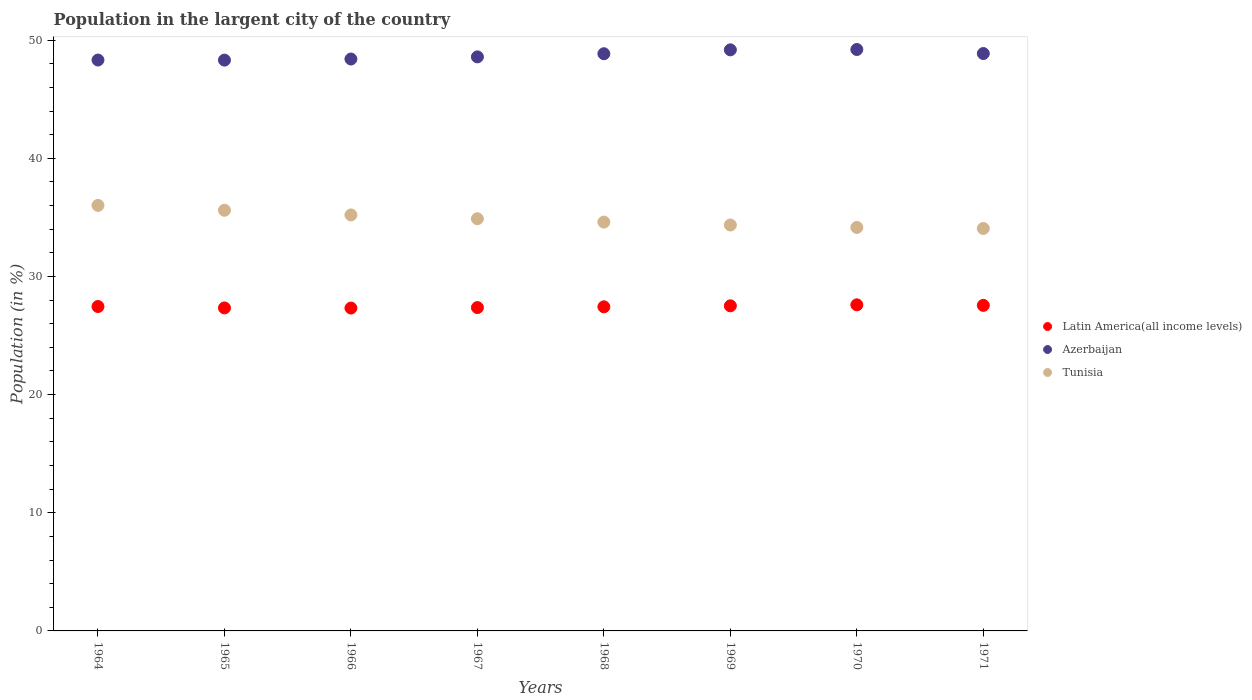What is the percentage of population in the largent city in Azerbaijan in 1965?
Ensure brevity in your answer.  48.31. Across all years, what is the maximum percentage of population in the largent city in Latin America(all income levels)?
Give a very brief answer. 27.6. Across all years, what is the minimum percentage of population in the largent city in Azerbaijan?
Give a very brief answer. 48.31. What is the total percentage of population in the largent city in Latin America(all income levels) in the graph?
Offer a very short reply. 219.59. What is the difference between the percentage of population in the largent city in Azerbaijan in 1964 and that in 1970?
Your response must be concise. -0.89. What is the difference between the percentage of population in the largent city in Tunisia in 1967 and the percentage of population in the largent city in Latin America(all income levels) in 1964?
Ensure brevity in your answer.  7.43. What is the average percentage of population in the largent city in Azerbaijan per year?
Give a very brief answer. 48.72. In the year 1967, what is the difference between the percentage of population in the largent city in Tunisia and percentage of population in the largent city in Azerbaijan?
Ensure brevity in your answer.  -13.7. What is the ratio of the percentage of population in the largent city in Tunisia in 1964 to that in 1965?
Keep it short and to the point. 1.01. Is the percentage of population in the largent city in Azerbaijan in 1968 less than that in 1970?
Your answer should be very brief. Yes. What is the difference between the highest and the second highest percentage of population in the largent city in Latin America(all income levels)?
Your answer should be compact. 0.05. What is the difference between the highest and the lowest percentage of population in the largent city in Latin America(all income levels)?
Make the answer very short. 0.27. How many dotlines are there?
Offer a terse response. 3. Are the values on the major ticks of Y-axis written in scientific E-notation?
Give a very brief answer. No. Does the graph contain any zero values?
Your response must be concise. No. Where does the legend appear in the graph?
Keep it short and to the point. Center right. How many legend labels are there?
Your answer should be compact. 3. What is the title of the graph?
Your answer should be compact. Population in the largent city of the country. What is the Population (in %) of Latin America(all income levels) in 1964?
Keep it short and to the point. 27.46. What is the Population (in %) in Azerbaijan in 1964?
Keep it short and to the point. 48.32. What is the Population (in %) in Tunisia in 1964?
Give a very brief answer. 36.02. What is the Population (in %) of Latin America(all income levels) in 1965?
Provide a short and direct response. 27.34. What is the Population (in %) in Azerbaijan in 1965?
Make the answer very short. 48.31. What is the Population (in %) of Tunisia in 1965?
Make the answer very short. 35.6. What is the Population (in %) of Latin America(all income levels) in 1966?
Make the answer very short. 27.33. What is the Population (in %) in Azerbaijan in 1966?
Your answer should be very brief. 48.4. What is the Population (in %) of Tunisia in 1966?
Give a very brief answer. 35.21. What is the Population (in %) of Latin America(all income levels) in 1967?
Give a very brief answer. 27.37. What is the Population (in %) of Azerbaijan in 1967?
Ensure brevity in your answer.  48.59. What is the Population (in %) in Tunisia in 1967?
Make the answer very short. 34.89. What is the Population (in %) in Latin America(all income levels) in 1968?
Offer a very short reply. 27.43. What is the Population (in %) in Azerbaijan in 1968?
Your response must be concise. 48.85. What is the Population (in %) of Tunisia in 1968?
Keep it short and to the point. 34.6. What is the Population (in %) of Latin America(all income levels) in 1969?
Make the answer very short. 27.52. What is the Population (in %) in Azerbaijan in 1969?
Offer a very short reply. 49.18. What is the Population (in %) of Tunisia in 1969?
Make the answer very short. 34.36. What is the Population (in %) in Latin America(all income levels) in 1970?
Give a very brief answer. 27.6. What is the Population (in %) in Azerbaijan in 1970?
Offer a very short reply. 49.21. What is the Population (in %) of Tunisia in 1970?
Offer a very short reply. 34.15. What is the Population (in %) in Latin America(all income levels) in 1971?
Your answer should be compact. 27.55. What is the Population (in %) of Azerbaijan in 1971?
Your response must be concise. 48.87. What is the Population (in %) of Tunisia in 1971?
Provide a short and direct response. 34.06. Across all years, what is the maximum Population (in %) in Latin America(all income levels)?
Give a very brief answer. 27.6. Across all years, what is the maximum Population (in %) of Azerbaijan?
Your answer should be very brief. 49.21. Across all years, what is the maximum Population (in %) in Tunisia?
Ensure brevity in your answer.  36.02. Across all years, what is the minimum Population (in %) in Latin America(all income levels)?
Your answer should be very brief. 27.33. Across all years, what is the minimum Population (in %) of Azerbaijan?
Ensure brevity in your answer.  48.31. Across all years, what is the minimum Population (in %) in Tunisia?
Offer a terse response. 34.06. What is the total Population (in %) in Latin America(all income levels) in the graph?
Make the answer very short. 219.59. What is the total Population (in %) in Azerbaijan in the graph?
Ensure brevity in your answer.  389.73. What is the total Population (in %) in Tunisia in the graph?
Ensure brevity in your answer.  278.89. What is the difference between the Population (in %) in Latin America(all income levels) in 1964 and that in 1965?
Offer a very short reply. 0.12. What is the difference between the Population (in %) in Azerbaijan in 1964 and that in 1965?
Offer a terse response. 0.01. What is the difference between the Population (in %) in Tunisia in 1964 and that in 1965?
Offer a very short reply. 0.41. What is the difference between the Population (in %) of Latin America(all income levels) in 1964 and that in 1966?
Your response must be concise. 0.13. What is the difference between the Population (in %) of Azerbaijan in 1964 and that in 1966?
Ensure brevity in your answer.  -0.09. What is the difference between the Population (in %) of Tunisia in 1964 and that in 1966?
Offer a terse response. 0.81. What is the difference between the Population (in %) in Latin America(all income levels) in 1964 and that in 1967?
Make the answer very short. 0.09. What is the difference between the Population (in %) of Azerbaijan in 1964 and that in 1967?
Your answer should be compact. -0.27. What is the difference between the Population (in %) of Tunisia in 1964 and that in 1967?
Your answer should be compact. 1.13. What is the difference between the Population (in %) of Latin America(all income levels) in 1964 and that in 1968?
Make the answer very short. 0.02. What is the difference between the Population (in %) in Azerbaijan in 1964 and that in 1968?
Ensure brevity in your answer.  -0.53. What is the difference between the Population (in %) of Tunisia in 1964 and that in 1968?
Provide a succinct answer. 1.41. What is the difference between the Population (in %) of Latin America(all income levels) in 1964 and that in 1969?
Provide a succinct answer. -0.06. What is the difference between the Population (in %) of Azerbaijan in 1964 and that in 1969?
Provide a short and direct response. -0.86. What is the difference between the Population (in %) of Tunisia in 1964 and that in 1969?
Offer a very short reply. 1.66. What is the difference between the Population (in %) of Latin America(all income levels) in 1964 and that in 1970?
Your answer should be very brief. -0.14. What is the difference between the Population (in %) of Azerbaijan in 1964 and that in 1970?
Provide a succinct answer. -0.89. What is the difference between the Population (in %) of Tunisia in 1964 and that in 1970?
Offer a very short reply. 1.87. What is the difference between the Population (in %) in Latin America(all income levels) in 1964 and that in 1971?
Provide a succinct answer. -0.1. What is the difference between the Population (in %) of Azerbaijan in 1964 and that in 1971?
Your answer should be very brief. -0.55. What is the difference between the Population (in %) of Tunisia in 1964 and that in 1971?
Your answer should be compact. 1.95. What is the difference between the Population (in %) in Latin America(all income levels) in 1965 and that in 1966?
Ensure brevity in your answer.  0.01. What is the difference between the Population (in %) of Azerbaijan in 1965 and that in 1966?
Keep it short and to the point. -0.09. What is the difference between the Population (in %) of Tunisia in 1965 and that in 1966?
Offer a terse response. 0.4. What is the difference between the Population (in %) of Latin America(all income levels) in 1965 and that in 1967?
Offer a very short reply. -0.03. What is the difference between the Population (in %) in Azerbaijan in 1965 and that in 1967?
Ensure brevity in your answer.  -0.27. What is the difference between the Population (in %) of Tunisia in 1965 and that in 1967?
Your answer should be compact. 0.72. What is the difference between the Population (in %) of Latin America(all income levels) in 1965 and that in 1968?
Your answer should be compact. -0.09. What is the difference between the Population (in %) in Azerbaijan in 1965 and that in 1968?
Your response must be concise. -0.54. What is the difference between the Population (in %) in Latin America(all income levels) in 1965 and that in 1969?
Offer a very short reply. -0.18. What is the difference between the Population (in %) in Azerbaijan in 1965 and that in 1969?
Give a very brief answer. -0.87. What is the difference between the Population (in %) in Tunisia in 1965 and that in 1969?
Your answer should be very brief. 1.25. What is the difference between the Population (in %) of Latin America(all income levels) in 1965 and that in 1970?
Your answer should be very brief. -0.26. What is the difference between the Population (in %) in Azerbaijan in 1965 and that in 1970?
Your answer should be compact. -0.9. What is the difference between the Population (in %) in Tunisia in 1965 and that in 1970?
Keep it short and to the point. 1.45. What is the difference between the Population (in %) in Latin America(all income levels) in 1965 and that in 1971?
Give a very brief answer. -0.22. What is the difference between the Population (in %) in Azerbaijan in 1965 and that in 1971?
Your answer should be very brief. -0.56. What is the difference between the Population (in %) of Tunisia in 1965 and that in 1971?
Provide a short and direct response. 1.54. What is the difference between the Population (in %) in Latin America(all income levels) in 1966 and that in 1967?
Provide a short and direct response. -0.04. What is the difference between the Population (in %) of Azerbaijan in 1966 and that in 1967?
Give a very brief answer. -0.18. What is the difference between the Population (in %) in Tunisia in 1966 and that in 1967?
Offer a very short reply. 0.32. What is the difference between the Population (in %) in Latin America(all income levels) in 1966 and that in 1968?
Offer a terse response. -0.1. What is the difference between the Population (in %) of Azerbaijan in 1966 and that in 1968?
Ensure brevity in your answer.  -0.45. What is the difference between the Population (in %) of Tunisia in 1966 and that in 1968?
Give a very brief answer. 0.61. What is the difference between the Population (in %) of Latin America(all income levels) in 1966 and that in 1969?
Provide a succinct answer. -0.19. What is the difference between the Population (in %) in Azerbaijan in 1966 and that in 1969?
Offer a terse response. -0.78. What is the difference between the Population (in %) in Tunisia in 1966 and that in 1969?
Give a very brief answer. 0.85. What is the difference between the Population (in %) in Latin America(all income levels) in 1966 and that in 1970?
Your answer should be very brief. -0.27. What is the difference between the Population (in %) in Azerbaijan in 1966 and that in 1970?
Your answer should be compact. -0.81. What is the difference between the Population (in %) in Tunisia in 1966 and that in 1970?
Keep it short and to the point. 1.06. What is the difference between the Population (in %) in Latin America(all income levels) in 1966 and that in 1971?
Make the answer very short. -0.23. What is the difference between the Population (in %) in Azerbaijan in 1966 and that in 1971?
Your response must be concise. -0.46. What is the difference between the Population (in %) of Tunisia in 1966 and that in 1971?
Provide a succinct answer. 1.15. What is the difference between the Population (in %) of Latin America(all income levels) in 1967 and that in 1968?
Your answer should be compact. -0.07. What is the difference between the Population (in %) of Azerbaijan in 1967 and that in 1968?
Your answer should be very brief. -0.27. What is the difference between the Population (in %) of Tunisia in 1967 and that in 1968?
Provide a succinct answer. 0.28. What is the difference between the Population (in %) in Latin America(all income levels) in 1967 and that in 1969?
Your answer should be very brief. -0.15. What is the difference between the Population (in %) of Azerbaijan in 1967 and that in 1969?
Your response must be concise. -0.6. What is the difference between the Population (in %) in Tunisia in 1967 and that in 1969?
Make the answer very short. 0.53. What is the difference between the Population (in %) of Latin America(all income levels) in 1967 and that in 1970?
Your answer should be compact. -0.23. What is the difference between the Population (in %) of Azerbaijan in 1967 and that in 1970?
Offer a very short reply. -0.62. What is the difference between the Population (in %) of Tunisia in 1967 and that in 1970?
Your answer should be very brief. 0.74. What is the difference between the Population (in %) of Latin America(all income levels) in 1967 and that in 1971?
Your answer should be compact. -0.19. What is the difference between the Population (in %) of Azerbaijan in 1967 and that in 1971?
Give a very brief answer. -0.28. What is the difference between the Population (in %) in Tunisia in 1967 and that in 1971?
Offer a terse response. 0.82. What is the difference between the Population (in %) in Latin America(all income levels) in 1968 and that in 1969?
Provide a short and direct response. -0.08. What is the difference between the Population (in %) of Azerbaijan in 1968 and that in 1969?
Make the answer very short. -0.33. What is the difference between the Population (in %) of Tunisia in 1968 and that in 1969?
Give a very brief answer. 0.25. What is the difference between the Population (in %) in Latin America(all income levels) in 1968 and that in 1970?
Ensure brevity in your answer.  -0.17. What is the difference between the Population (in %) of Azerbaijan in 1968 and that in 1970?
Give a very brief answer. -0.36. What is the difference between the Population (in %) of Tunisia in 1968 and that in 1970?
Offer a terse response. 0.45. What is the difference between the Population (in %) in Latin America(all income levels) in 1968 and that in 1971?
Offer a terse response. -0.12. What is the difference between the Population (in %) of Azerbaijan in 1968 and that in 1971?
Provide a short and direct response. -0.02. What is the difference between the Population (in %) of Tunisia in 1968 and that in 1971?
Offer a very short reply. 0.54. What is the difference between the Population (in %) in Latin America(all income levels) in 1969 and that in 1970?
Your answer should be very brief. -0.08. What is the difference between the Population (in %) in Azerbaijan in 1969 and that in 1970?
Provide a short and direct response. -0.03. What is the difference between the Population (in %) in Tunisia in 1969 and that in 1970?
Make the answer very short. 0.21. What is the difference between the Population (in %) in Latin America(all income levels) in 1969 and that in 1971?
Your answer should be very brief. -0.04. What is the difference between the Population (in %) in Azerbaijan in 1969 and that in 1971?
Your answer should be very brief. 0.31. What is the difference between the Population (in %) of Tunisia in 1969 and that in 1971?
Ensure brevity in your answer.  0.29. What is the difference between the Population (in %) of Latin America(all income levels) in 1970 and that in 1971?
Offer a terse response. 0.05. What is the difference between the Population (in %) in Azerbaijan in 1970 and that in 1971?
Keep it short and to the point. 0.34. What is the difference between the Population (in %) of Tunisia in 1970 and that in 1971?
Provide a succinct answer. 0.09. What is the difference between the Population (in %) of Latin America(all income levels) in 1964 and the Population (in %) of Azerbaijan in 1965?
Keep it short and to the point. -20.86. What is the difference between the Population (in %) of Latin America(all income levels) in 1964 and the Population (in %) of Tunisia in 1965?
Your answer should be very brief. -8.15. What is the difference between the Population (in %) in Azerbaijan in 1964 and the Population (in %) in Tunisia in 1965?
Provide a short and direct response. 12.71. What is the difference between the Population (in %) of Latin America(all income levels) in 1964 and the Population (in %) of Azerbaijan in 1966?
Your response must be concise. -20.95. What is the difference between the Population (in %) in Latin America(all income levels) in 1964 and the Population (in %) in Tunisia in 1966?
Your response must be concise. -7.75. What is the difference between the Population (in %) of Azerbaijan in 1964 and the Population (in %) of Tunisia in 1966?
Your answer should be compact. 13.11. What is the difference between the Population (in %) of Latin America(all income levels) in 1964 and the Population (in %) of Azerbaijan in 1967?
Provide a short and direct response. -21.13. What is the difference between the Population (in %) in Latin America(all income levels) in 1964 and the Population (in %) in Tunisia in 1967?
Provide a short and direct response. -7.43. What is the difference between the Population (in %) in Azerbaijan in 1964 and the Population (in %) in Tunisia in 1967?
Offer a terse response. 13.43. What is the difference between the Population (in %) of Latin America(all income levels) in 1964 and the Population (in %) of Azerbaijan in 1968?
Provide a short and direct response. -21.4. What is the difference between the Population (in %) of Latin America(all income levels) in 1964 and the Population (in %) of Tunisia in 1968?
Make the answer very short. -7.15. What is the difference between the Population (in %) in Azerbaijan in 1964 and the Population (in %) in Tunisia in 1968?
Make the answer very short. 13.72. What is the difference between the Population (in %) in Latin America(all income levels) in 1964 and the Population (in %) in Azerbaijan in 1969?
Provide a succinct answer. -21.73. What is the difference between the Population (in %) in Latin America(all income levels) in 1964 and the Population (in %) in Tunisia in 1969?
Make the answer very short. -6.9. What is the difference between the Population (in %) in Azerbaijan in 1964 and the Population (in %) in Tunisia in 1969?
Give a very brief answer. 13.96. What is the difference between the Population (in %) in Latin America(all income levels) in 1964 and the Population (in %) in Azerbaijan in 1970?
Ensure brevity in your answer.  -21.75. What is the difference between the Population (in %) of Latin America(all income levels) in 1964 and the Population (in %) of Tunisia in 1970?
Offer a very short reply. -6.69. What is the difference between the Population (in %) of Azerbaijan in 1964 and the Population (in %) of Tunisia in 1970?
Keep it short and to the point. 14.17. What is the difference between the Population (in %) in Latin America(all income levels) in 1964 and the Population (in %) in Azerbaijan in 1971?
Your answer should be very brief. -21.41. What is the difference between the Population (in %) of Latin America(all income levels) in 1964 and the Population (in %) of Tunisia in 1971?
Provide a short and direct response. -6.61. What is the difference between the Population (in %) in Azerbaijan in 1964 and the Population (in %) in Tunisia in 1971?
Keep it short and to the point. 14.26. What is the difference between the Population (in %) of Latin America(all income levels) in 1965 and the Population (in %) of Azerbaijan in 1966?
Give a very brief answer. -21.07. What is the difference between the Population (in %) of Latin America(all income levels) in 1965 and the Population (in %) of Tunisia in 1966?
Your answer should be compact. -7.87. What is the difference between the Population (in %) of Azerbaijan in 1965 and the Population (in %) of Tunisia in 1966?
Your response must be concise. 13.1. What is the difference between the Population (in %) of Latin America(all income levels) in 1965 and the Population (in %) of Azerbaijan in 1967?
Provide a short and direct response. -21.25. What is the difference between the Population (in %) in Latin America(all income levels) in 1965 and the Population (in %) in Tunisia in 1967?
Your response must be concise. -7.55. What is the difference between the Population (in %) of Azerbaijan in 1965 and the Population (in %) of Tunisia in 1967?
Your answer should be compact. 13.43. What is the difference between the Population (in %) of Latin America(all income levels) in 1965 and the Population (in %) of Azerbaijan in 1968?
Provide a succinct answer. -21.51. What is the difference between the Population (in %) in Latin America(all income levels) in 1965 and the Population (in %) in Tunisia in 1968?
Ensure brevity in your answer.  -7.26. What is the difference between the Population (in %) of Azerbaijan in 1965 and the Population (in %) of Tunisia in 1968?
Offer a very short reply. 13.71. What is the difference between the Population (in %) of Latin America(all income levels) in 1965 and the Population (in %) of Azerbaijan in 1969?
Provide a succinct answer. -21.84. What is the difference between the Population (in %) in Latin America(all income levels) in 1965 and the Population (in %) in Tunisia in 1969?
Your answer should be compact. -7.02. What is the difference between the Population (in %) in Azerbaijan in 1965 and the Population (in %) in Tunisia in 1969?
Your response must be concise. 13.95. What is the difference between the Population (in %) in Latin America(all income levels) in 1965 and the Population (in %) in Azerbaijan in 1970?
Your answer should be compact. -21.87. What is the difference between the Population (in %) in Latin America(all income levels) in 1965 and the Population (in %) in Tunisia in 1970?
Offer a terse response. -6.81. What is the difference between the Population (in %) in Azerbaijan in 1965 and the Population (in %) in Tunisia in 1970?
Give a very brief answer. 14.16. What is the difference between the Population (in %) of Latin America(all income levels) in 1965 and the Population (in %) of Azerbaijan in 1971?
Offer a very short reply. -21.53. What is the difference between the Population (in %) in Latin America(all income levels) in 1965 and the Population (in %) in Tunisia in 1971?
Provide a short and direct response. -6.72. What is the difference between the Population (in %) in Azerbaijan in 1965 and the Population (in %) in Tunisia in 1971?
Give a very brief answer. 14.25. What is the difference between the Population (in %) of Latin America(all income levels) in 1966 and the Population (in %) of Azerbaijan in 1967?
Give a very brief answer. -21.26. What is the difference between the Population (in %) in Latin America(all income levels) in 1966 and the Population (in %) in Tunisia in 1967?
Provide a short and direct response. -7.56. What is the difference between the Population (in %) of Azerbaijan in 1966 and the Population (in %) of Tunisia in 1967?
Provide a short and direct response. 13.52. What is the difference between the Population (in %) in Latin America(all income levels) in 1966 and the Population (in %) in Azerbaijan in 1968?
Provide a short and direct response. -21.52. What is the difference between the Population (in %) of Latin America(all income levels) in 1966 and the Population (in %) of Tunisia in 1968?
Give a very brief answer. -7.27. What is the difference between the Population (in %) of Azerbaijan in 1966 and the Population (in %) of Tunisia in 1968?
Offer a terse response. 13.8. What is the difference between the Population (in %) of Latin America(all income levels) in 1966 and the Population (in %) of Azerbaijan in 1969?
Make the answer very short. -21.85. What is the difference between the Population (in %) in Latin America(all income levels) in 1966 and the Population (in %) in Tunisia in 1969?
Keep it short and to the point. -7.03. What is the difference between the Population (in %) of Azerbaijan in 1966 and the Population (in %) of Tunisia in 1969?
Keep it short and to the point. 14.05. What is the difference between the Population (in %) in Latin America(all income levels) in 1966 and the Population (in %) in Azerbaijan in 1970?
Your answer should be compact. -21.88. What is the difference between the Population (in %) in Latin America(all income levels) in 1966 and the Population (in %) in Tunisia in 1970?
Offer a terse response. -6.82. What is the difference between the Population (in %) of Azerbaijan in 1966 and the Population (in %) of Tunisia in 1970?
Your response must be concise. 14.25. What is the difference between the Population (in %) in Latin America(all income levels) in 1966 and the Population (in %) in Azerbaijan in 1971?
Your response must be concise. -21.54. What is the difference between the Population (in %) in Latin America(all income levels) in 1966 and the Population (in %) in Tunisia in 1971?
Provide a short and direct response. -6.74. What is the difference between the Population (in %) of Azerbaijan in 1966 and the Population (in %) of Tunisia in 1971?
Offer a very short reply. 14.34. What is the difference between the Population (in %) of Latin America(all income levels) in 1967 and the Population (in %) of Azerbaijan in 1968?
Offer a terse response. -21.48. What is the difference between the Population (in %) of Latin America(all income levels) in 1967 and the Population (in %) of Tunisia in 1968?
Make the answer very short. -7.24. What is the difference between the Population (in %) in Azerbaijan in 1967 and the Population (in %) in Tunisia in 1968?
Make the answer very short. 13.98. What is the difference between the Population (in %) in Latin America(all income levels) in 1967 and the Population (in %) in Azerbaijan in 1969?
Provide a succinct answer. -21.81. What is the difference between the Population (in %) in Latin America(all income levels) in 1967 and the Population (in %) in Tunisia in 1969?
Ensure brevity in your answer.  -6.99. What is the difference between the Population (in %) in Azerbaijan in 1967 and the Population (in %) in Tunisia in 1969?
Offer a very short reply. 14.23. What is the difference between the Population (in %) of Latin America(all income levels) in 1967 and the Population (in %) of Azerbaijan in 1970?
Provide a succinct answer. -21.84. What is the difference between the Population (in %) in Latin America(all income levels) in 1967 and the Population (in %) in Tunisia in 1970?
Keep it short and to the point. -6.78. What is the difference between the Population (in %) of Azerbaijan in 1967 and the Population (in %) of Tunisia in 1970?
Provide a succinct answer. 14.44. What is the difference between the Population (in %) in Latin America(all income levels) in 1967 and the Population (in %) in Azerbaijan in 1971?
Your answer should be very brief. -21.5. What is the difference between the Population (in %) of Latin America(all income levels) in 1967 and the Population (in %) of Tunisia in 1971?
Your answer should be very brief. -6.7. What is the difference between the Population (in %) of Azerbaijan in 1967 and the Population (in %) of Tunisia in 1971?
Your answer should be very brief. 14.52. What is the difference between the Population (in %) of Latin America(all income levels) in 1968 and the Population (in %) of Azerbaijan in 1969?
Offer a terse response. -21.75. What is the difference between the Population (in %) of Latin America(all income levels) in 1968 and the Population (in %) of Tunisia in 1969?
Give a very brief answer. -6.92. What is the difference between the Population (in %) in Azerbaijan in 1968 and the Population (in %) in Tunisia in 1969?
Keep it short and to the point. 14.5. What is the difference between the Population (in %) of Latin America(all income levels) in 1968 and the Population (in %) of Azerbaijan in 1970?
Your response must be concise. -21.78. What is the difference between the Population (in %) of Latin America(all income levels) in 1968 and the Population (in %) of Tunisia in 1970?
Your answer should be very brief. -6.72. What is the difference between the Population (in %) in Azerbaijan in 1968 and the Population (in %) in Tunisia in 1970?
Ensure brevity in your answer.  14.7. What is the difference between the Population (in %) in Latin America(all income levels) in 1968 and the Population (in %) in Azerbaijan in 1971?
Provide a succinct answer. -21.44. What is the difference between the Population (in %) of Latin America(all income levels) in 1968 and the Population (in %) of Tunisia in 1971?
Offer a very short reply. -6.63. What is the difference between the Population (in %) in Azerbaijan in 1968 and the Population (in %) in Tunisia in 1971?
Make the answer very short. 14.79. What is the difference between the Population (in %) of Latin America(all income levels) in 1969 and the Population (in %) of Azerbaijan in 1970?
Offer a very short reply. -21.69. What is the difference between the Population (in %) of Latin America(all income levels) in 1969 and the Population (in %) of Tunisia in 1970?
Provide a short and direct response. -6.63. What is the difference between the Population (in %) of Azerbaijan in 1969 and the Population (in %) of Tunisia in 1970?
Provide a succinct answer. 15.03. What is the difference between the Population (in %) of Latin America(all income levels) in 1969 and the Population (in %) of Azerbaijan in 1971?
Keep it short and to the point. -21.35. What is the difference between the Population (in %) in Latin America(all income levels) in 1969 and the Population (in %) in Tunisia in 1971?
Offer a terse response. -6.55. What is the difference between the Population (in %) of Azerbaijan in 1969 and the Population (in %) of Tunisia in 1971?
Keep it short and to the point. 15.12. What is the difference between the Population (in %) in Latin America(all income levels) in 1970 and the Population (in %) in Azerbaijan in 1971?
Your answer should be compact. -21.27. What is the difference between the Population (in %) of Latin America(all income levels) in 1970 and the Population (in %) of Tunisia in 1971?
Offer a very short reply. -6.46. What is the difference between the Population (in %) in Azerbaijan in 1970 and the Population (in %) in Tunisia in 1971?
Give a very brief answer. 15.15. What is the average Population (in %) of Latin America(all income levels) per year?
Offer a very short reply. 27.45. What is the average Population (in %) in Azerbaijan per year?
Give a very brief answer. 48.72. What is the average Population (in %) in Tunisia per year?
Provide a succinct answer. 34.86. In the year 1964, what is the difference between the Population (in %) of Latin America(all income levels) and Population (in %) of Azerbaijan?
Provide a short and direct response. -20.86. In the year 1964, what is the difference between the Population (in %) in Latin America(all income levels) and Population (in %) in Tunisia?
Give a very brief answer. -8.56. In the year 1964, what is the difference between the Population (in %) of Azerbaijan and Population (in %) of Tunisia?
Your answer should be very brief. 12.3. In the year 1965, what is the difference between the Population (in %) of Latin America(all income levels) and Population (in %) of Azerbaijan?
Your answer should be very brief. -20.97. In the year 1965, what is the difference between the Population (in %) of Latin America(all income levels) and Population (in %) of Tunisia?
Keep it short and to the point. -8.27. In the year 1965, what is the difference between the Population (in %) in Azerbaijan and Population (in %) in Tunisia?
Keep it short and to the point. 12.71. In the year 1966, what is the difference between the Population (in %) in Latin America(all income levels) and Population (in %) in Azerbaijan?
Provide a short and direct response. -21.08. In the year 1966, what is the difference between the Population (in %) in Latin America(all income levels) and Population (in %) in Tunisia?
Offer a terse response. -7.88. In the year 1966, what is the difference between the Population (in %) in Azerbaijan and Population (in %) in Tunisia?
Keep it short and to the point. 13.2. In the year 1967, what is the difference between the Population (in %) of Latin America(all income levels) and Population (in %) of Azerbaijan?
Your answer should be compact. -21.22. In the year 1967, what is the difference between the Population (in %) of Latin America(all income levels) and Population (in %) of Tunisia?
Make the answer very short. -7.52. In the year 1967, what is the difference between the Population (in %) in Azerbaijan and Population (in %) in Tunisia?
Ensure brevity in your answer.  13.7. In the year 1968, what is the difference between the Population (in %) in Latin America(all income levels) and Population (in %) in Azerbaijan?
Offer a very short reply. -21.42. In the year 1968, what is the difference between the Population (in %) in Latin America(all income levels) and Population (in %) in Tunisia?
Provide a short and direct response. -7.17. In the year 1968, what is the difference between the Population (in %) of Azerbaijan and Population (in %) of Tunisia?
Give a very brief answer. 14.25. In the year 1969, what is the difference between the Population (in %) in Latin America(all income levels) and Population (in %) in Azerbaijan?
Ensure brevity in your answer.  -21.66. In the year 1969, what is the difference between the Population (in %) in Latin America(all income levels) and Population (in %) in Tunisia?
Your response must be concise. -6.84. In the year 1969, what is the difference between the Population (in %) in Azerbaijan and Population (in %) in Tunisia?
Provide a short and direct response. 14.82. In the year 1970, what is the difference between the Population (in %) of Latin America(all income levels) and Population (in %) of Azerbaijan?
Offer a very short reply. -21.61. In the year 1970, what is the difference between the Population (in %) in Latin America(all income levels) and Population (in %) in Tunisia?
Offer a terse response. -6.55. In the year 1970, what is the difference between the Population (in %) of Azerbaijan and Population (in %) of Tunisia?
Offer a terse response. 15.06. In the year 1971, what is the difference between the Population (in %) in Latin America(all income levels) and Population (in %) in Azerbaijan?
Offer a terse response. -21.32. In the year 1971, what is the difference between the Population (in %) of Latin America(all income levels) and Population (in %) of Tunisia?
Make the answer very short. -6.51. In the year 1971, what is the difference between the Population (in %) in Azerbaijan and Population (in %) in Tunisia?
Offer a terse response. 14.81. What is the ratio of the Population (in %) of Azerbaijan in 1964 to that in 1965?
Keep it short and to the point. 1. What is the ratio of the Population (in %) of Tunisia in 1964 to that in 1965?
Offer a very short reply. 1.01. What is the ratio of the Population (in %) in Tunisia in 1964 to that in 1966?
Offer a terse response. 1.02. What is the ratio of the Population (in %) in Latin America(all income levels) in 1964 to that in 1967?
Make the answer very short. 1. What is the ratio of the Population (in %) of Tunisia in 1964 to that in 1967?
Your answer should be very brief. 1.03. What is the ratio of the Population (in %) of Azerbaijan in 1964 to that in 1968?
Your response must be concise. 0.99. What is the ratio of the Population (in %) in Tunisia in 1964 to that in 1968?
Offer a very short reply. 1.04. What is the ratio of the Population (in %) of Azerbaijan in 1964 to that in 1969?
Your answer should be compact. 0.98. What is the ratio of the Population (in %) in Tunisia in 1964 to that in 1969?
Ensure brevity in your answer.  1.05. What is the ratio of the Population (in %) in Azerbaijan in 1964 to that in 1970?
Provide a short and direct response. 0.98. What is the ratio of the Population (in %) in Tunisia in 1964 to that in 1970?
Provide a succinct answer. 1.05. What is the ratio of the Population (in %) of Latin America(all income levels) in 1964 to that in 1971?
Your answer should be compact. 1. What is the ratio of the Population (in %) of Azerbaijan in 1964 to that in 1971?
Keep it short and to the point. 0.99. What is the ratio of the Population (in %) of Tunisia in 1964 to that in 1971?
Keep it short and to the point. 1.06. What is the ratio of the Population (in %) of Latin America(all income levels) in 1965 to that in 1966?
Make the answer very short. 1. What is the ratio of the Population (in %) of Azerbaijan in 1965 to that in 1966?
Provide a short and direct response. 1. What is the ratio of the Population (in %) of Tunisia in 1965 to that in 1966?
Offer a very short reply. 1.01. What is the ratio of the Population (in %) of Latin America(all income levels) in 1965 to that in 1967?
Offer a very short reply. 1. What is the ratio of the Population (in %) in Azerbaijan in 1965 to that in 1967?
Offer a very short reply. 0.99. What is the ratio of the Population (in %) of Tunisia in 1965 to that in 1967?
Give a very brief answer. 1.02. What is the ratio of the Population (in %) in Latin America(all income levels) in 1965 to that in 1968?
Your answer should be very brief. 1. What is the ratio of the Population (in %) in Azerbaijan in 1965 to that in 1968?
Offer a terse response. 0.99. What is the ratio of the Population (in %) in Tunisia in 1965 to that in 1968?
Give a very brief answer. 1.03. What is the ratio of the Population (in %) of Latin America(all income levels) in 1965 to that in 1969?
Provide a succinct answer. 0.99. What is the ratio of the Population (in %) in Azerbaijan in 1965 to that in 1969?
Your response must be concise. 0.98. What is the ratio of the Population (in %) in Tunisia in 1965 to that in 1969?
Give a very brief answer. 1.04. What is the ratio of the Population (in %) in Azerbaijan in 1965 to that in 1970?
Ensure brevity in your answer.  0.98. What is the ratio of the Population (in %) in Tunisia in 1965 to that in 1970?
Provide a succinct answer. 1.04. What is the ratio of the Population (in %) in Latin America(all income levels) in 1965 to that in 1971?
Make the answer very short. 0.99. What is the ratio of the Population (in %) of Azerbaijan in 1965 to that in 1971?
Your response must be concise. 0.99. What is the ratio of the Population (in %) in Tunisia in 1965 to that in 1971?
Your answer should be compact. 1.05. What is the ratio of the Population (in %) of Latin America(all income levels) in 1966 to that in 1967?
Ensure brevity in your answer.  1. What is the ratio of the Population (in %) of Azerbaijan in 1966 to that in 1967?
Ensure brevity in your answer.  1. What is the ratio of the Population (in %) of Tunisia in 1966 to that in 1967?
Offer a very short reply. 1.01. What is the ratio of the Population (in %) of Latin America(all income levels) in 1966 to that in 1968?
Provide a succinct answer. 1. What is the ratio of the Population (in %) in Azerbaijan in 1966 to that in 1968?
Offer a very short reply. 0.99. What is the ratio of the Population (in %) in Tunisia in 1966 to that in 1968?
Your response must be concise. 1.02. What is the ratio of the Population (in %) in Latin America(all income levels) in 1966 to that in 1969?
Ensure brevity in your answer.  0.99. What is the ratio of the Population (in %) in Azerbaijan in 1966 to that in 1969?
Keep it short and to the point. 0.98. What is the ratio of the Population (in %) of Tunisia in 1966 to that in 1969?
Provide a succinct answer. 1.02. What is the ratio of the Population (in %) of Azerbaijan in 1966 to that in 1970?
Provide a succinct answer. 0.98. What is the ratio of the Population (in %) in Tunisia in 1966 to that in 1970?
Give a very brief answer. 1.03. What is the ratio of the Population (in %) of Latin America(all income levels) in 1966 to that in 1971?
Keep it short and to the point. 0.99. What is the ratio of the Population (in %) of Tunisia in 1966 to that in 1971?
Your response must be concise. 1.03. What is the ratio of the Population (in %) of Tunisia in 1967 to that in 1968?
Provide a succinct answer. 1.01. What is the ratio of the Population (in %) in Azerbaijan in 1967 to that in 1969?
Offer a terse response. 0.99. What is the ratio of the Population (in %) of Tunisia in 1967 to that in 1969?
Provide a short and direct response. 1.02. What is the ratio of the Population (in %) in Latin America(all income levels) in 1967 to that in 1970?
Make the answer very short. 0.99. What is the ratio of the Population (in %) in Azerbaijan in 1967 to that in 1970?
Make the answer very short. 0.99. What is the ratio of the Population (in %) in Tunisia in 1967 to that in 1970?
Provide a short and direct response. 1.02. What is the ratio of the Population (in %) in Latin America(all income levels) in 1967 to that in 1971?
Ensure brevity in your answer.  0.99. What is the ratio of the Population (in %) of Tunisia in 1967 to that in 1971?
Offer a very short reply. 1.02. What is the ratio of the Population (in %) of Tunisia in 1968 to that in 1969?
Ensure brevity in your answer.  1.01. What is the ratio of the Population (in %) in Azerbaijan in 1968 to that in 1970?
Make the answer very short. 0.99. What is the ratio of the Population (in %) in Tunisia in 1968 to that in 1970?
Ensure brevity in your answer.  1.01. What is the ratio of the Population (in %) in Latin America(all income levels) in 1968 to that in 1971?
Ensure brevity in your answer.  1. What is the ratio of the Population (in %) of Azerbaijan in 1968 to that in 1971?
Offer a very short reply. 1. What is the ratio of the Population (in %) of Tunisia in 1968 to that in 1971?
Keep it short and to the point. 1.02. What is the ratio of the Population (in %) of Latin America(all income levels) in 1969 to that in 1970?
Provide a short and direct response. 1. What is the ratio of the Population (in %) in Latin America(all income levels) in 1969 to that in 1971?
Keep it short and to the point. 1. What is the ratio of the Population (in %) of Azerbaijan in 1969 to that in 1971?
Your response must be concise. 1.01. What is the ratio of the Population (in %) in Tunisia in 1969 to that in 1971?
Offer a very short reply. 1.01. What is the ratio of the Population (in %) in Latin America(all income levels) in 1970 to that in 1971?
Give a very brief answer. 1. What is the ratio of the Population (in %) in Tunisia in 1970 to that in 1971?
Provide a short and direct response. 1. What is the difference between the highest and the second highest Population (in %) of Latin America(all income levels)?
Keep it short and to the point. 0.05. What is the difference between the highest and the second highest Population (in %) of Azerbaijan?
Provide a succinct answer. 0.03. What is the difference between the highest and the second highest Population (in %) in Tunisia?
Your answer should be compact. 0.41. What is the difference between the highest and the lowest Population (in %) in Latin America(all income levels)?
Provide a succinct answer. 0.27. What is the difference between the highest and the lowest Population (in %) in Azerbaijan?
Ensure brevity in your answer.  0.9. What is the difference between the highest and the lowest Population (in %) in Tunisia?
Your response must be concise. 1.95. 